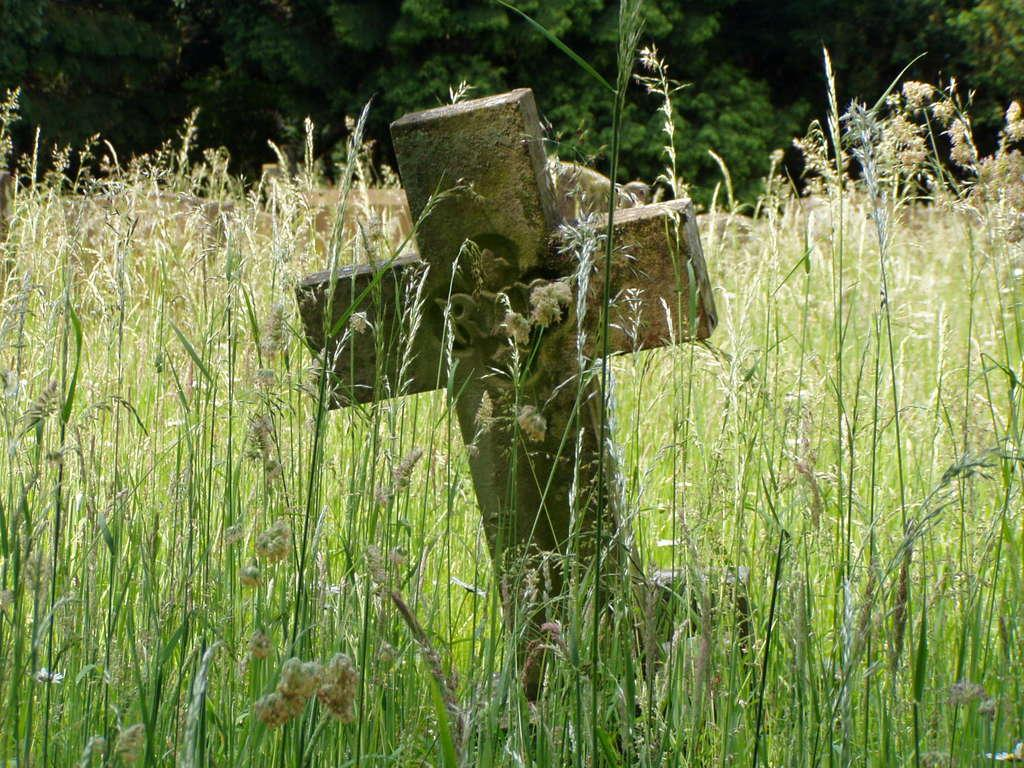What symbol can be seen on a wall in the image? There is a plus symbol on a wall in the image. What type of vegetation is visible in the background of the image? There are plants and trees in the background of the image. What color are the plants and trees in the image? The plants and trees are in green color. What type of fruit is hanging from the substance on the wall in the image? There is no fruit or substance present on the wall in the image; it only features a plus symbol. 